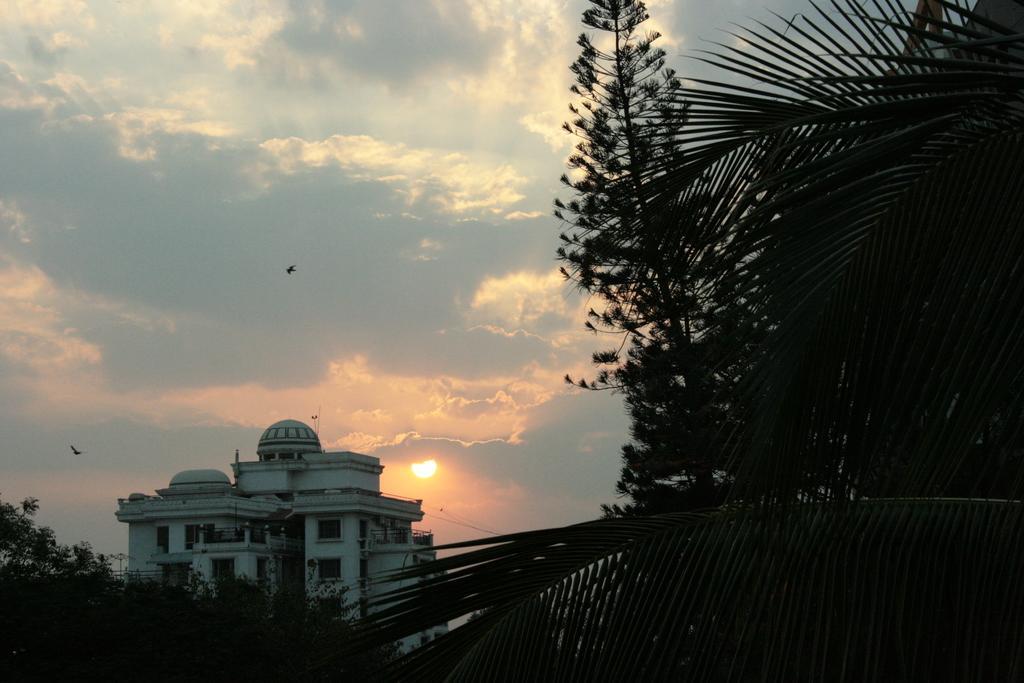In one or two sentences, can you explain what this image depicts? In this picture there is a building and there are trees. At the top there is sky and there are clouds and there are birds flying and there is a sun. 